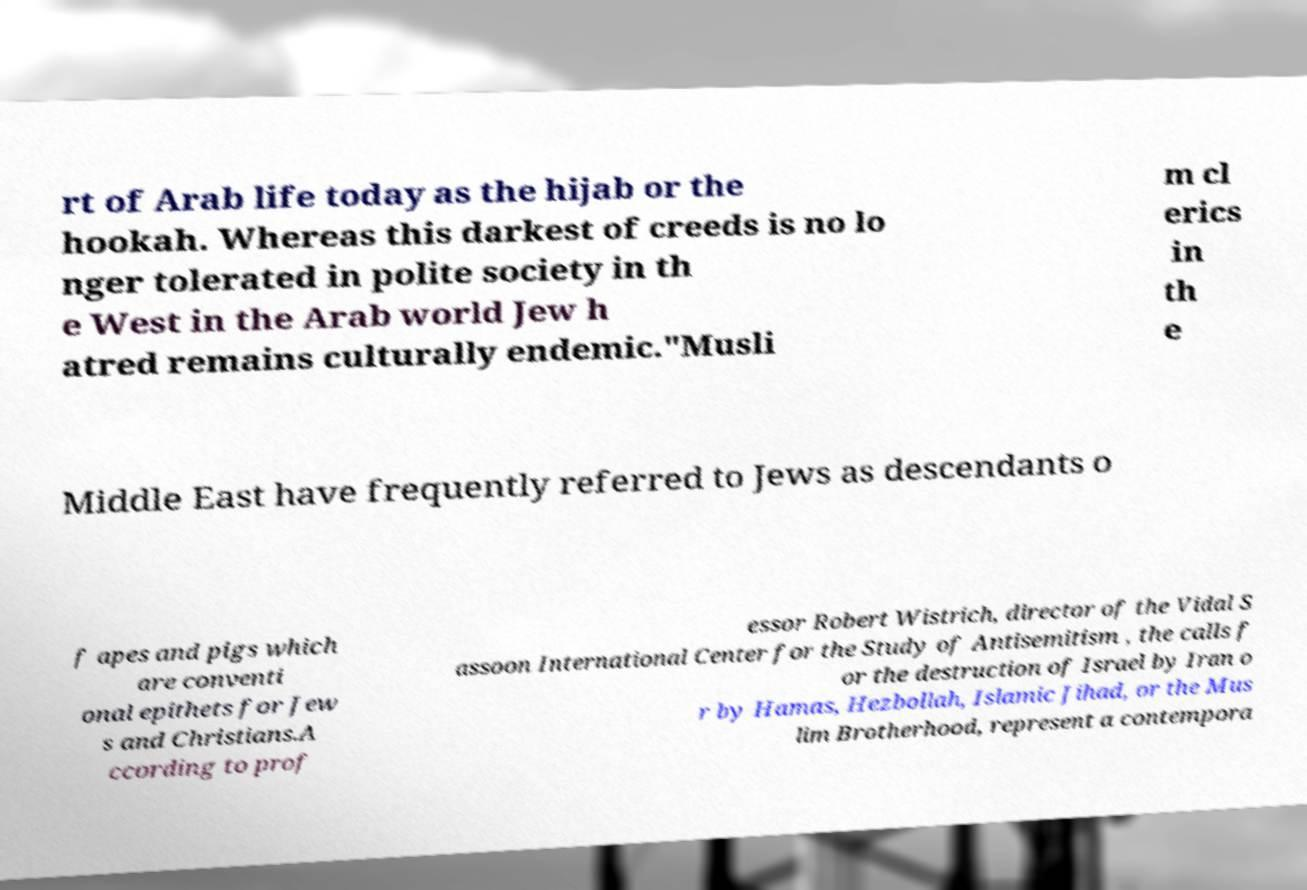For documentation purposes, I need the text within this image transcribed. Could you provide that? rt of Arab life today as the hijab or the hookah. Whereas this darkest of creeds is no lo nger tolerated in polite society in th e West in the Arab world Jew h atred remains culturally endemic."Musli m cl erics in th e Middle East have frequently referred to Jews as descendants o f apes and pigs which are conventi onal epithets for Jew s and Christians.A ccording to prof essor Robert Wistrich, director of the Vidal S assoon International Center for the Study of Antisemitism , the calls f or the destruction of Israel by Iran o r by Hamas, Hezbollah, Islamic Jihad, or the Mus lim Brotherhood, represent a contempora 